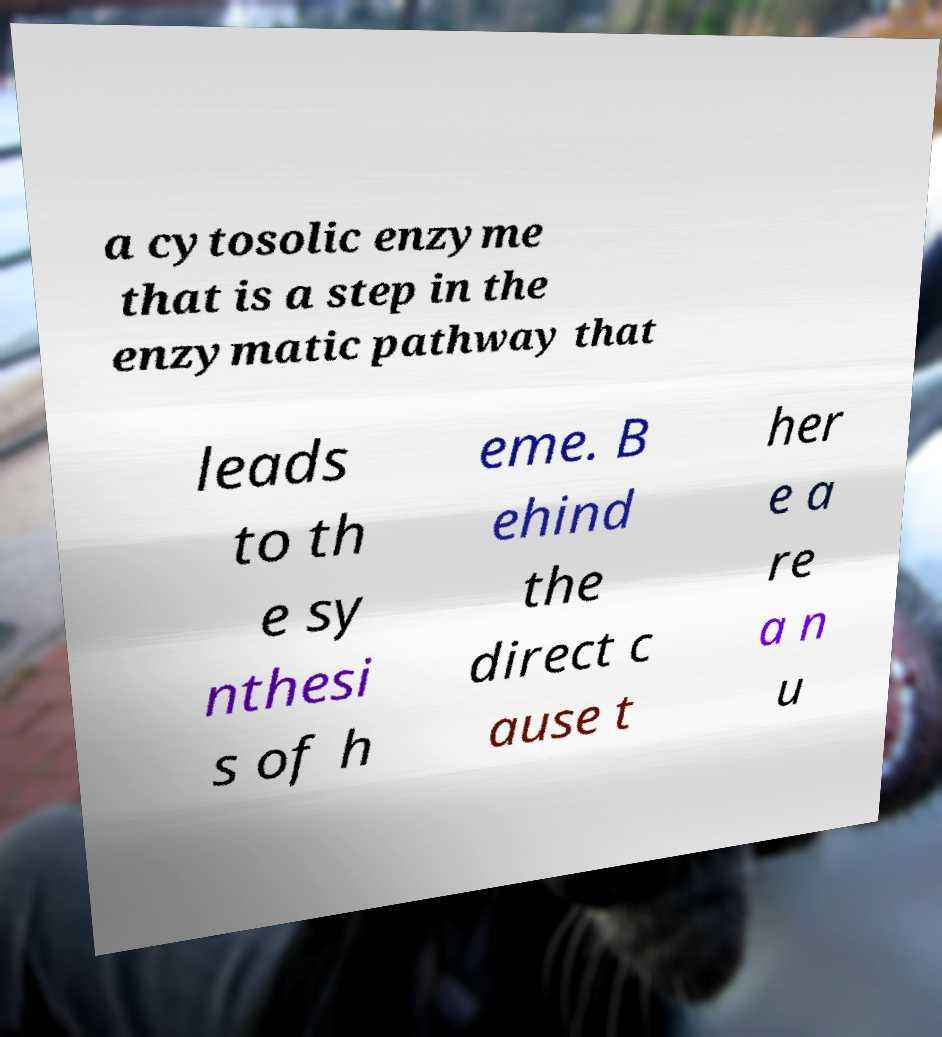Could you extract and type out the text from this image? a cytosolic enzyme that is a step in the enzymatic pathway that leads to th e sy nthesi s of h eme. B ehind the direct c ause t her e a re a n u 